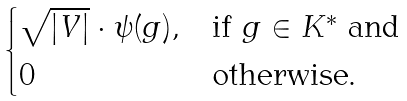Convert formula to latex. <formula><loc_0><loc_0><loc_500><loc_500>\begin{cases} \sqrt { | V | } \cdot \psi ( g ) , & \text {if $g \in K^{*}$ and} \\ 0 & \text {otherwise.} \\ \end{cases}</formula> 